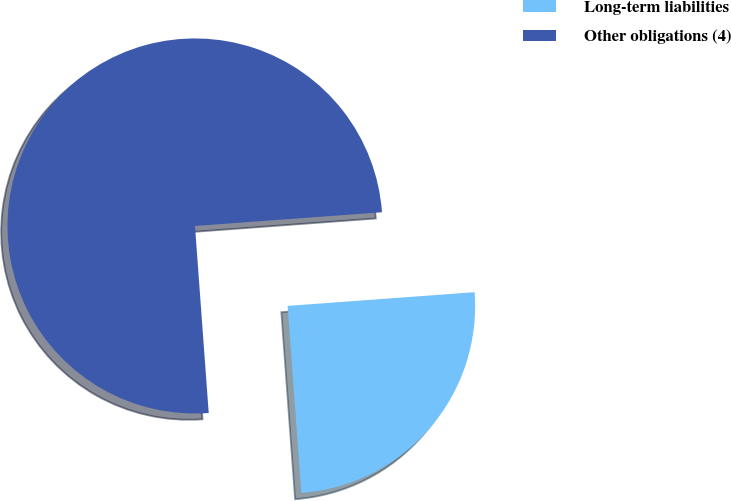Convert chart. <chart><loc_0><loc_0><loc_500><loc_500><pie_chart><fcel>Long-term liabilities<fcel>Other obligations (4)<nl><fcel>25.0%<fcel>75.0%<nl></chart> 